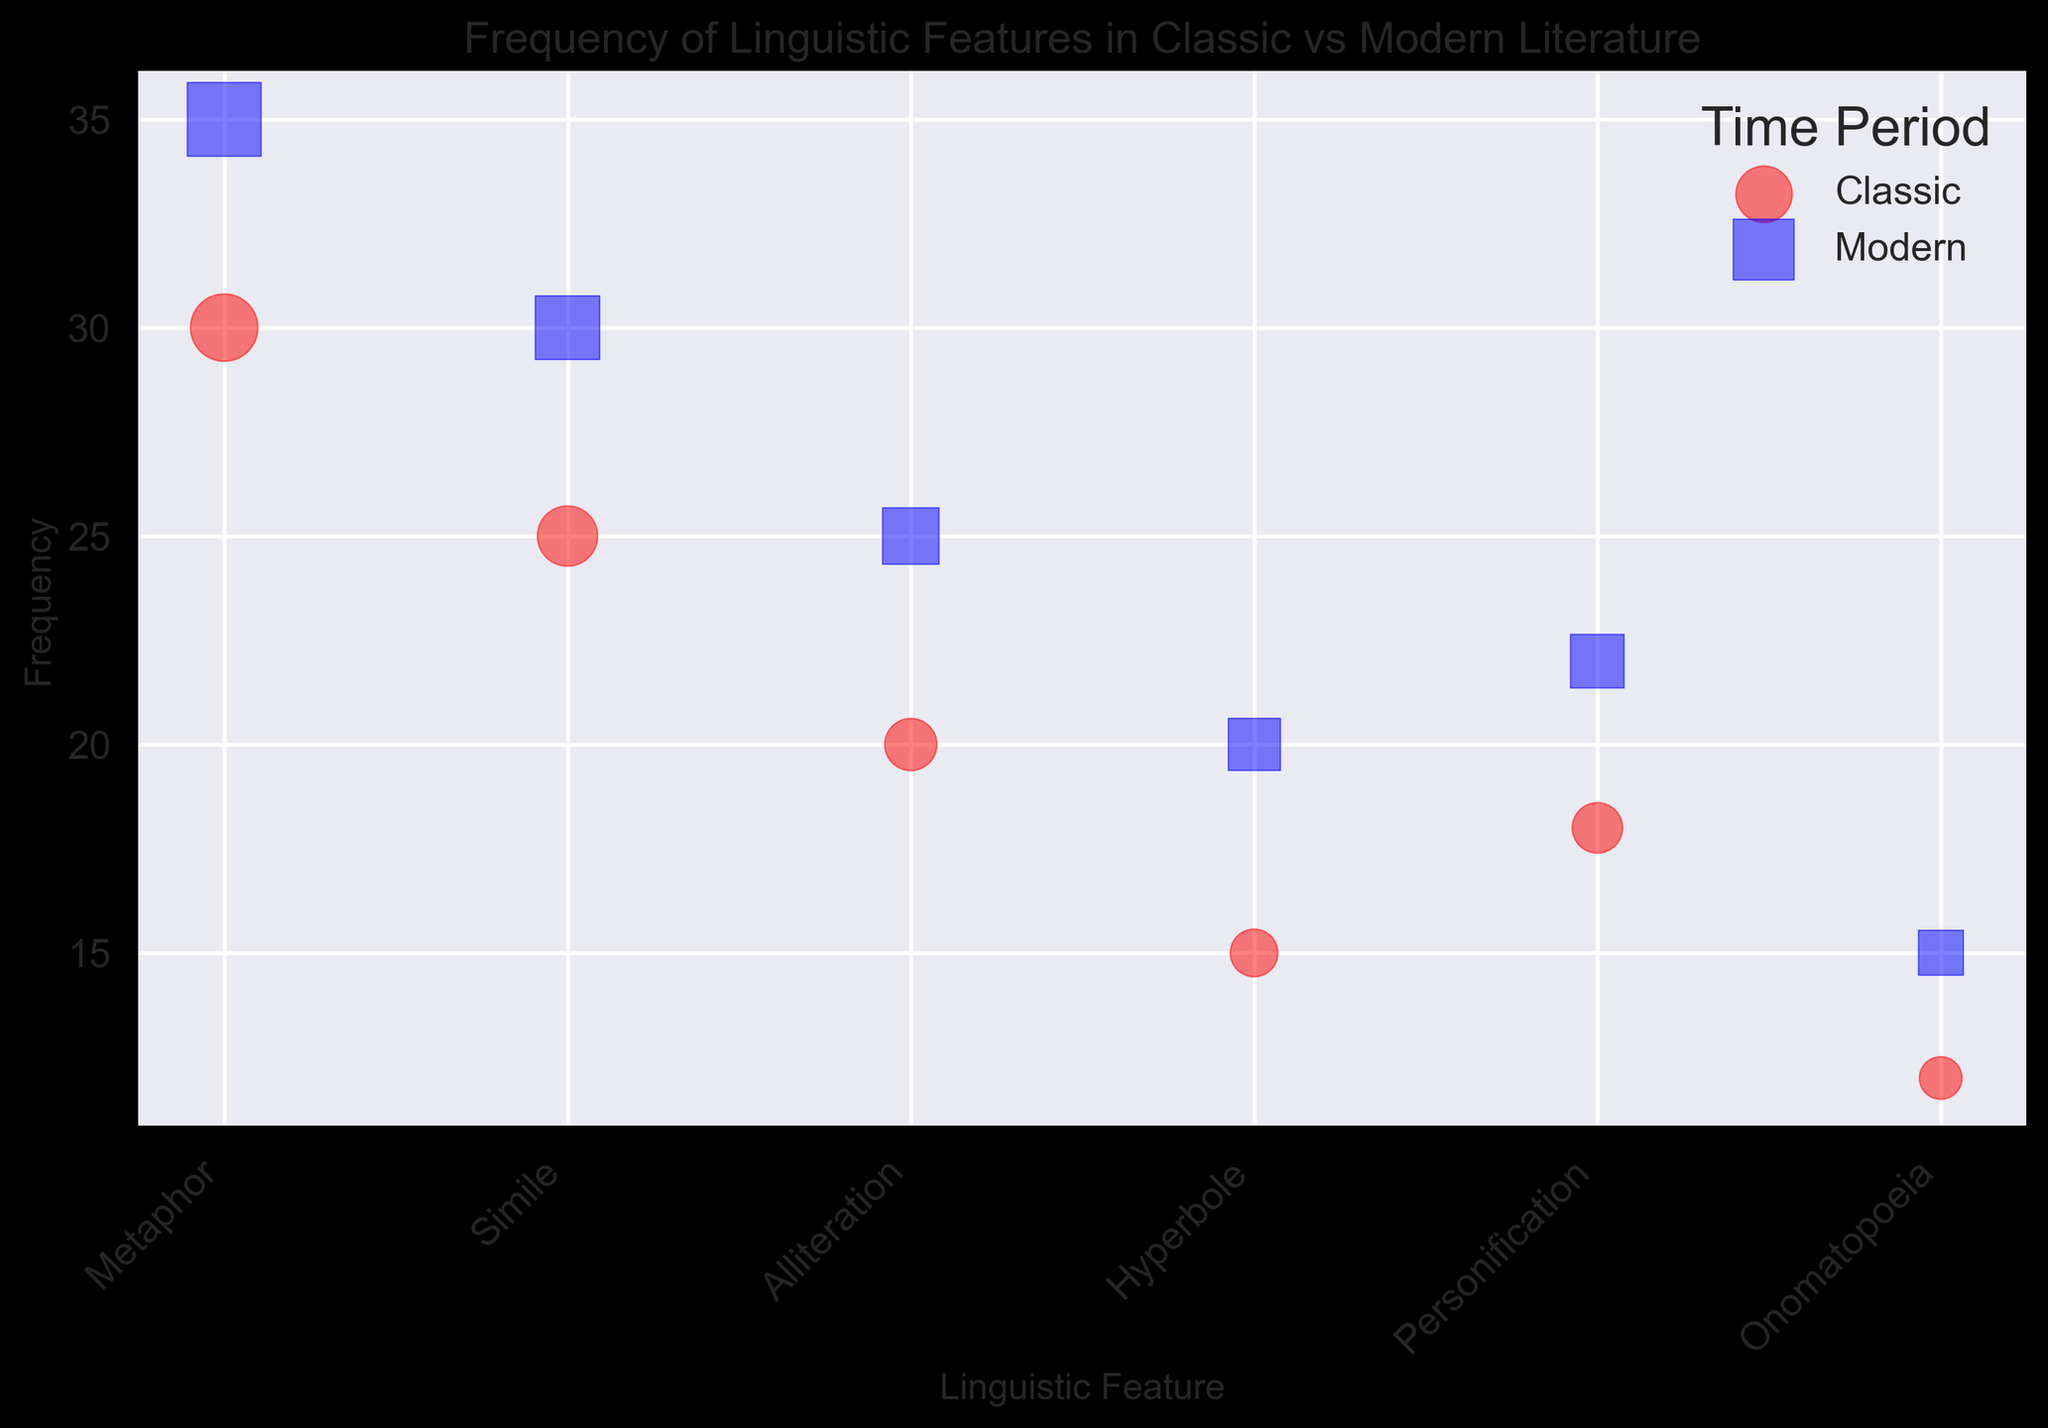Which time period has a higher frequency of metaphors? `Observe the y-axis values for metaphors in both Classic and Modern categories; Modern has a higher frequency (35) compared to Classic (30)`
Answer: Modern What is the visual difference between representations of Classic and Modern literature in the plot? `Classic literature points are marked using red circles, and Modern literature points are marked using blue squares`
Answer: Red circles for Classic and blue squares for Modern How much greater is the frequency of alliteration in modern literature compared to classic literature? `Examining the y-axis values, modern alliteration has a frequency of 25 and classic alliteration has a frequency of 20; the difference is 25 - 20 = 5`
Answer: 5 Which linguistic feature has the largest bubble size in the modern literature category? `The bubble size is proportional to the 'Impact' value multiplied by 10. Modern metaphors have the largest bubble size due to their highest impact of 60`
Answer: Metaphor If we consider the average frequency of similes and hyperboles in both time periods, which period has a higher average? `For Classic: (Simile (25) + Hyperbole (15))/2 = 20; For Modern: (Simile (30) + Hyperbole (20))/2 = 25; Modern has the higher average`
Answer: Modern Which linguistic feature shows the least frequency in classic literature? `Checking the y-axis for the smallest value within Classic data points, onomatopoeia has the lowest frequency at 12`
Answer: Onomatopoeia The frequency of which linguistic feature increases the most when comparing Classic and Modern periods? `By comparing the corresponding frequencies in both periods: personification (22 vs. 18), the increase is 22 - 18 = 4; this is the highest increase compared to other features.`
Answer: Personification For which linguistic feature is the difference in impact between Classic and Modern literature the smallest? `Comparing the 'Impact' values: differences are metaphor (60 - 50 = 10), simile (45 - 40 = 5), alliteration (35 - 30 = 5), hyperbole (30 - 25 = 5), personification (32 - 28 = 4), onomatopoeia (22 - 20 = 2); the smallest difference is 2 for onomatopoeia`
Answer: Onomatopoeia 